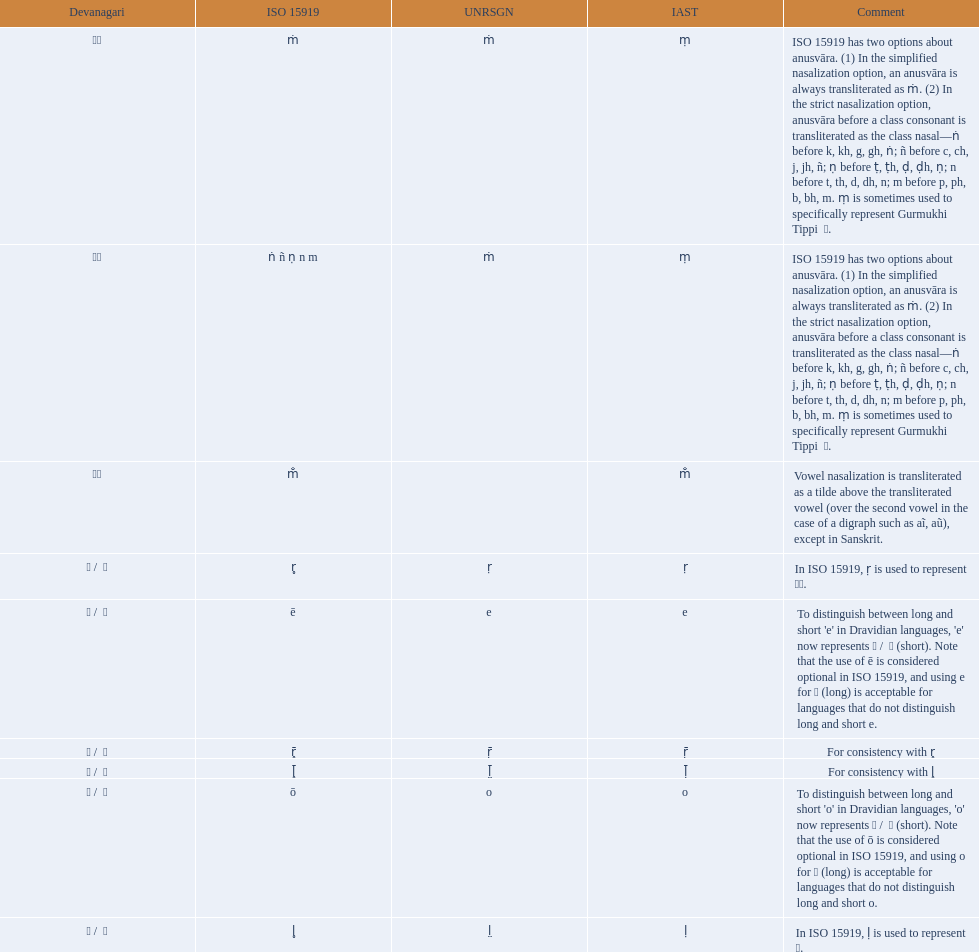What iast is listed before the o? E. 